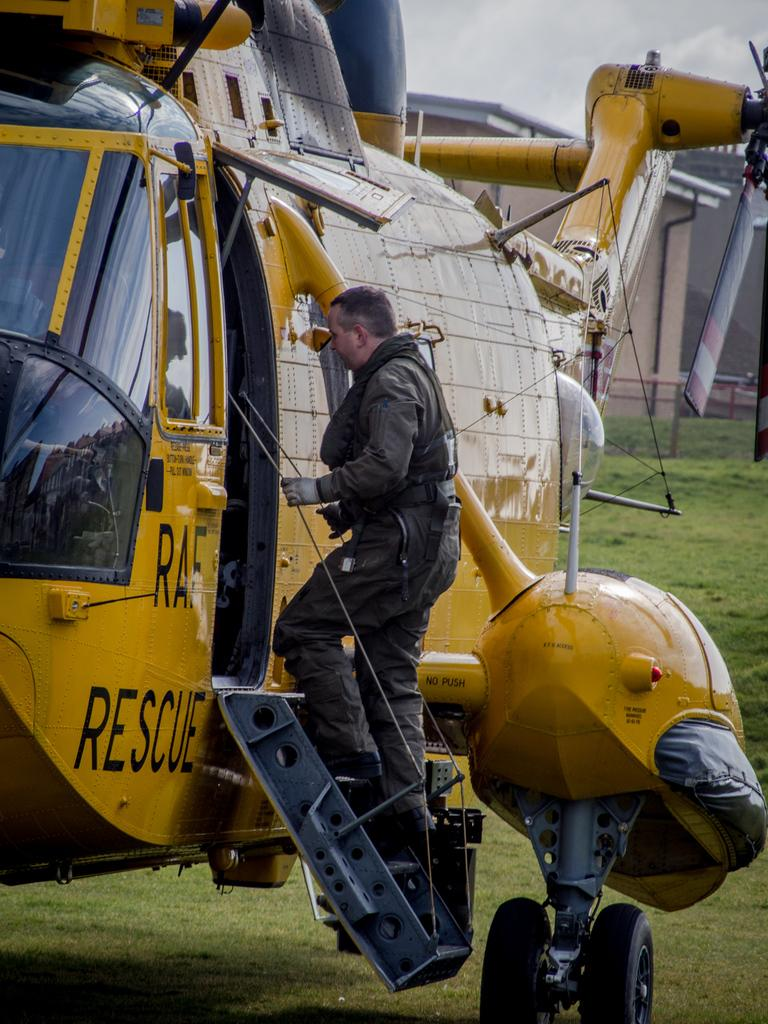<image>
Describe the image concisely. A man is climbing aboard a yellow rescue helicopter. 